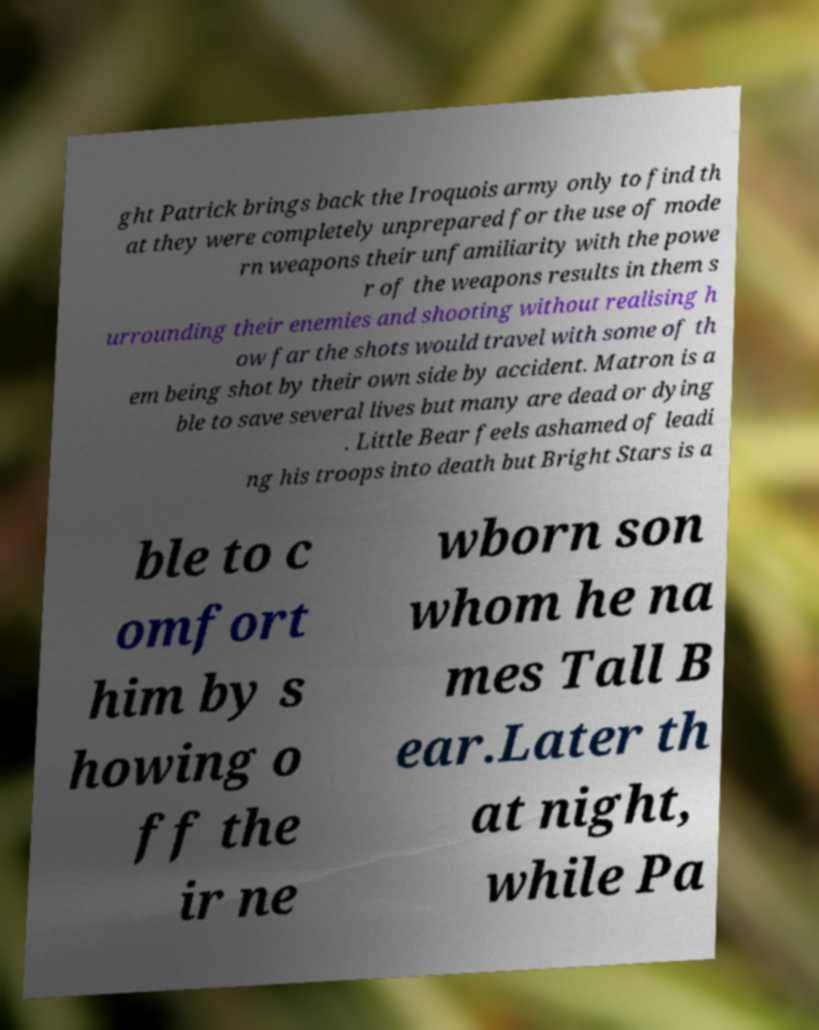Can you read and provide the text displayed in the image?This photo seems to have some interesting text. Can you extract and type it out for me? ght Patrick brings back the Iroquois army only to find th at they were completely unprepared for the use of mode rn weapons their unfamiliarity with the powe r of the weapons results in them s urrounding their enemies and shooting without realising h ow far the shots would travel with some of th em being shot by their own side by accident. Matron is a ble to save several lives but many are dead or dying . Little Bear feels ashamed of leadi ng his troops into death but Bright Stars is a ble to c omfort him by s howing o ff the ir ne wborn son whom he na mes Tall B ear.Later th at night, while Pa 